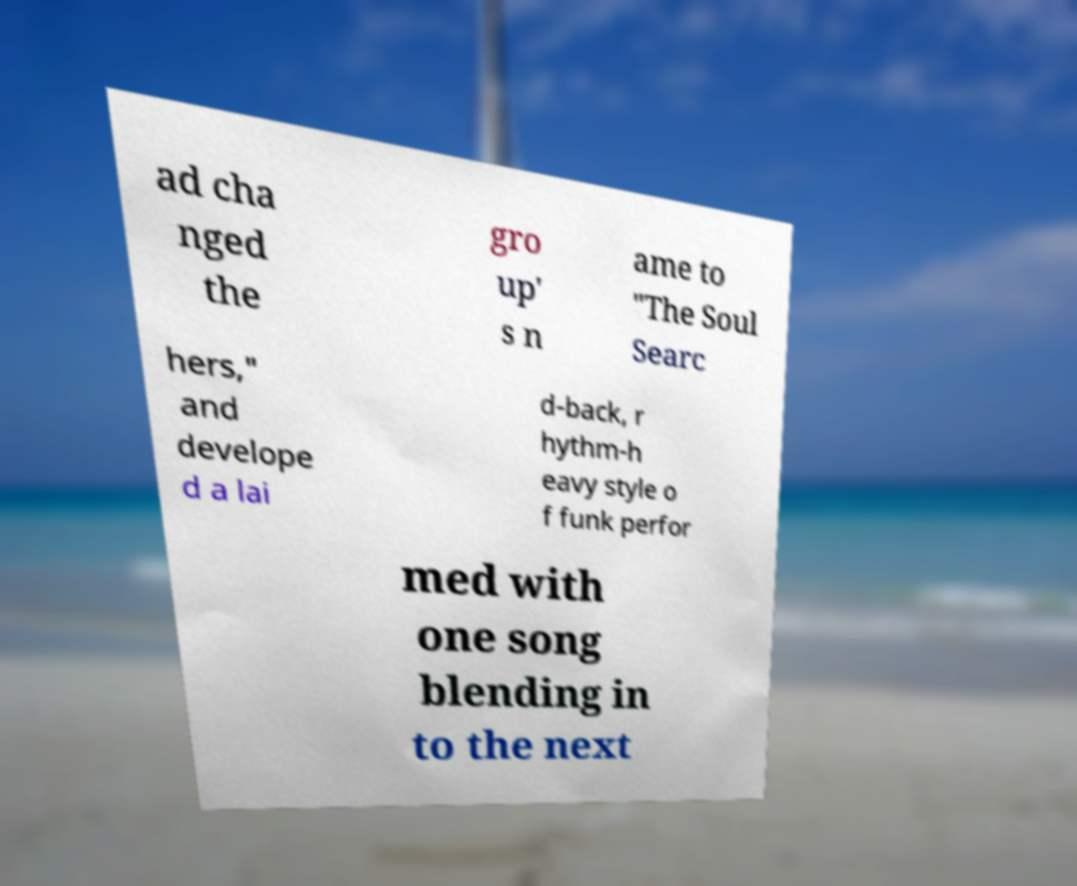Please identify and transcribe the text found in this image. ad cha nged the gro up' s n ame to "The Soul Searc hers," and develope d a lai d-back, r hythm-h eavy style o f funk perfor med with one song blending in to the next 